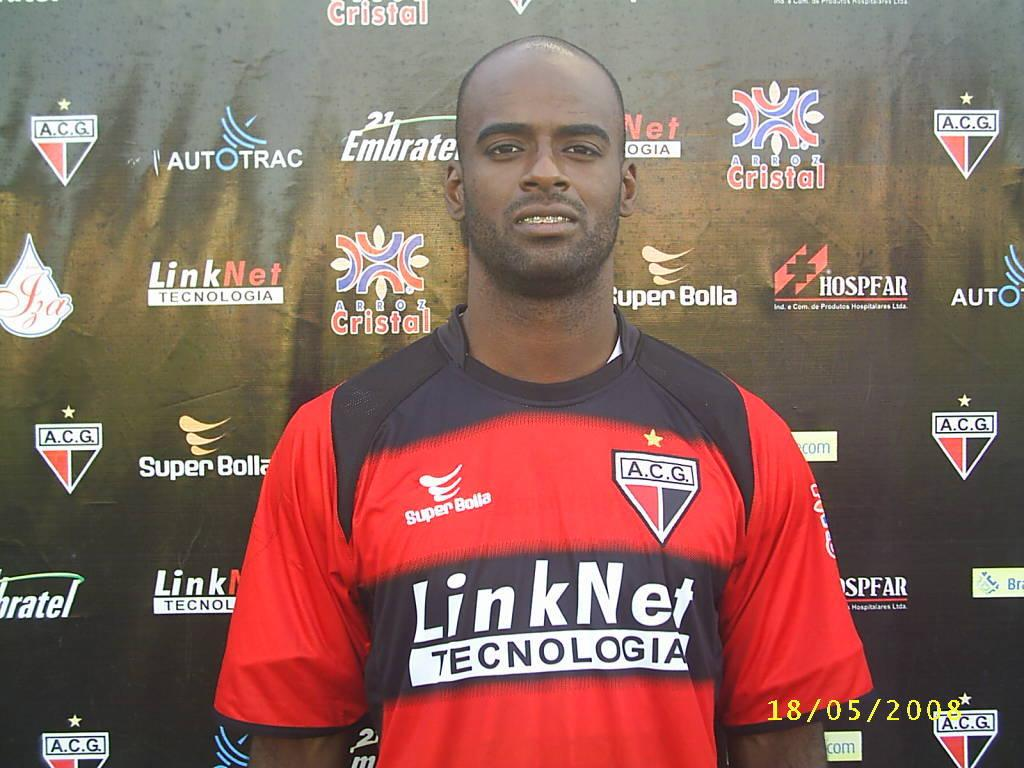<image>
Offer a succinct explanation of the picture presented. A man in an A.C.G. shirt stands in front of a black wall covered in logos. 